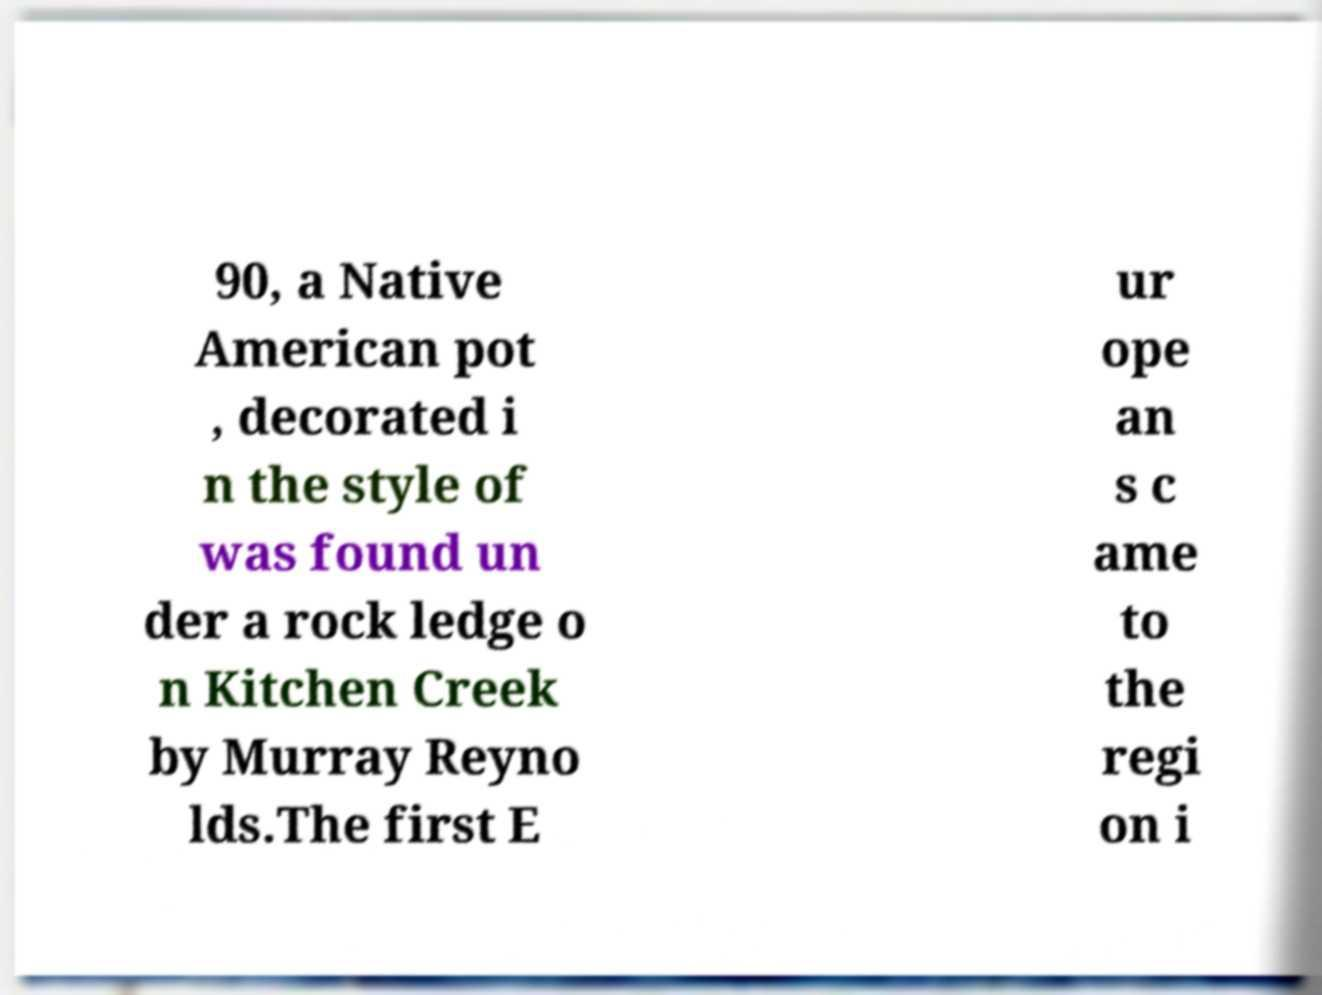There's text embedded in this image that I need extracted. Can you transcribe it verbatim? 90, a Native American pot , decorated i n the style of was found un der a rock ledge o n Kitchen Creek by Murray Reyno lds.The first E ur ope an s c ame to the regi on i 